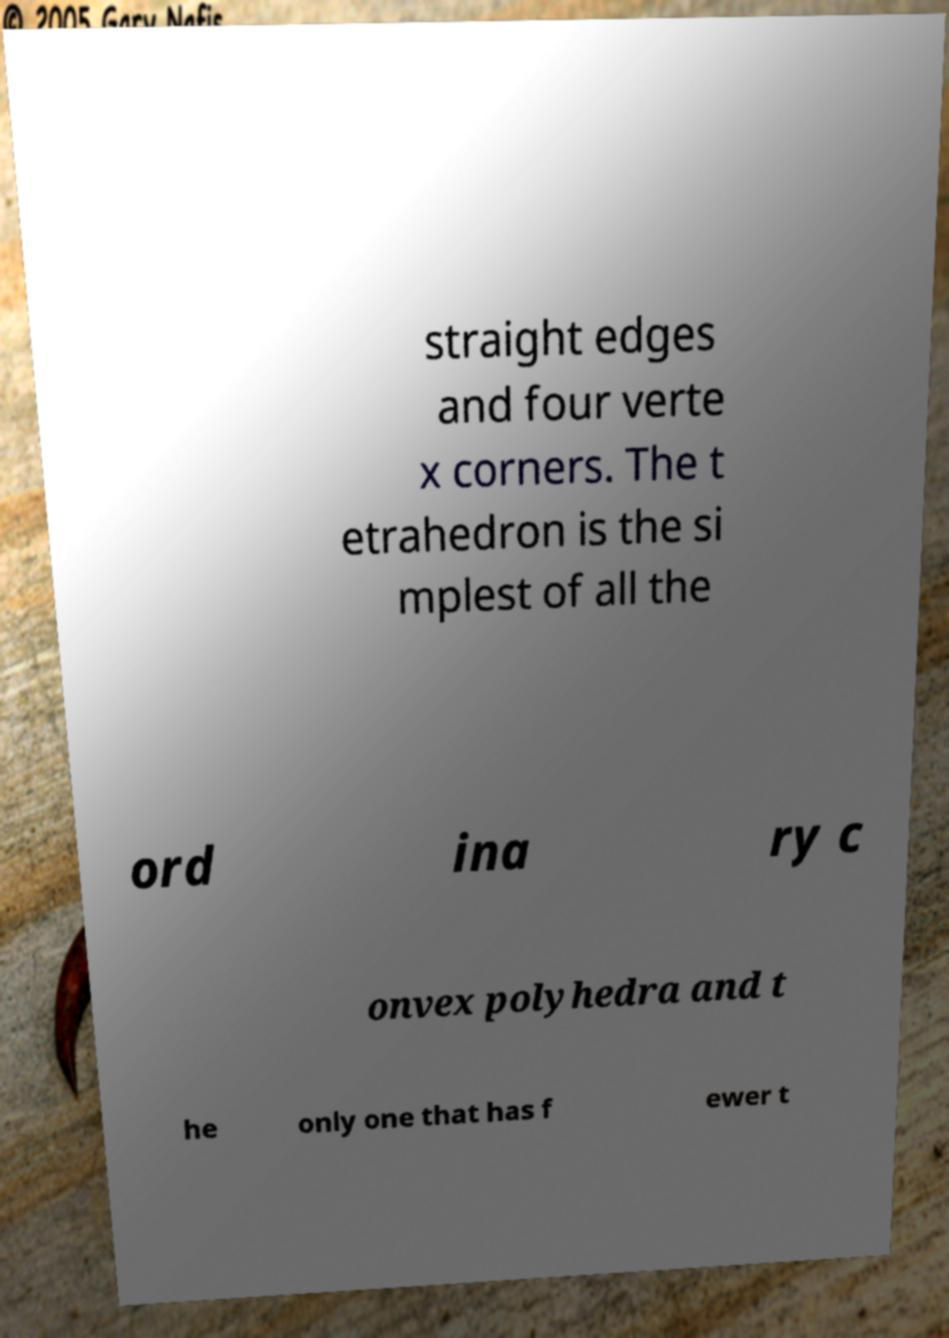Can you accurately transcribe the text from the provided image for me? straight edges and four verte x corners. The t etrahedron is the si mplest of all the ord ina ry c onvex polyhedra and t he only one that has f ewer t 